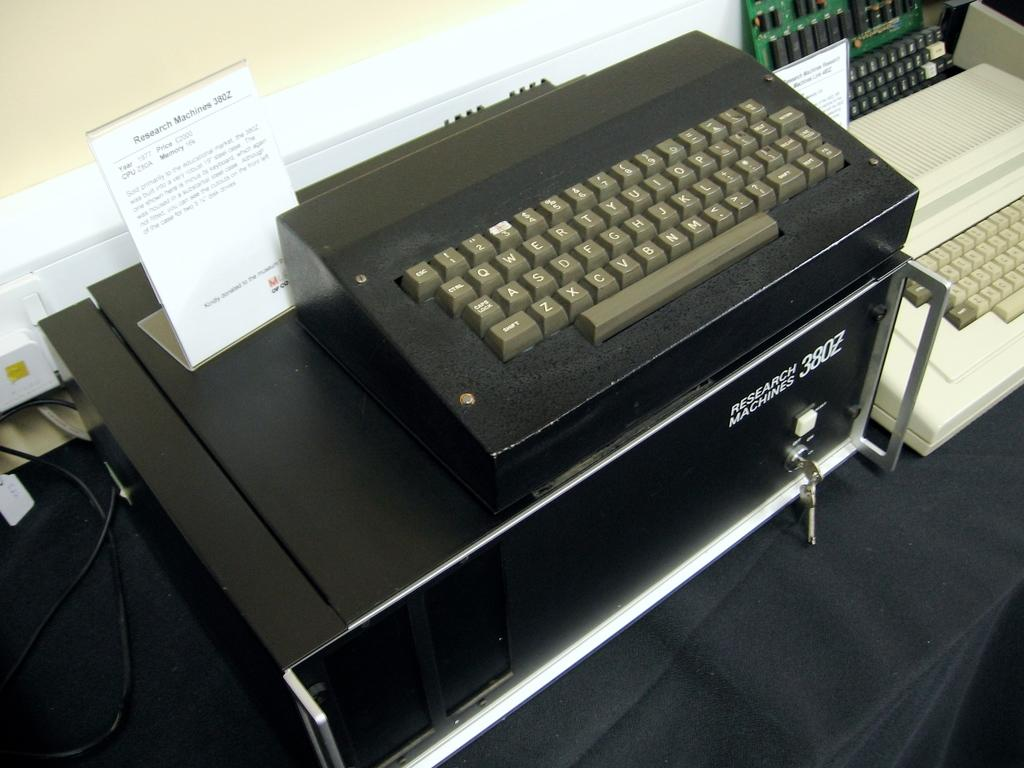<image>
Describe the image concisely. A type writer is above a cabinet with a model number of 380Z. 